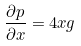Convert formula to latex. <formula><loc_0><loc_0><loc_500><loc_500>\frac { \partial p } { \partial x } = 4 x g</formula> 